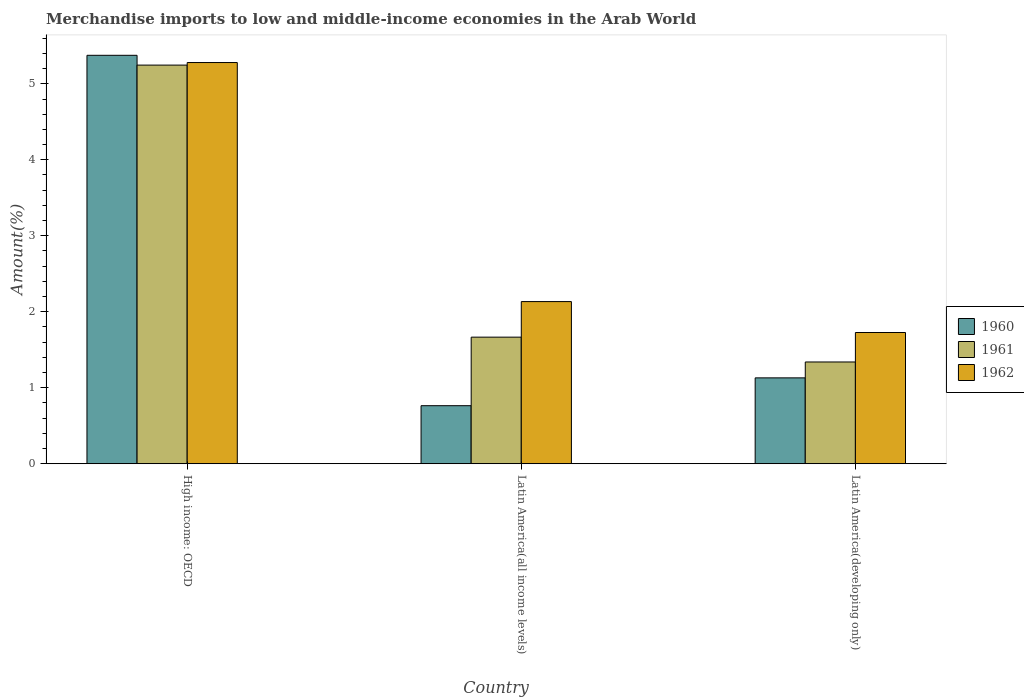Are the number of bars per tick equal to the number of legend labels?
Ensure brevity in your answer.  Yes. Are the number of bars on each tick of the X-axis equal?
Give a very brief answer. Yes. How many bars are there on the 1st tick from the left?
Make the answer very short. 3. How many bars are there on the 3rd tick from the right?
Ensure brevity in your answer.  3. What is the label of the 1st group of bars from the left?
Your answer should be very brief. High income: OECD. In how many cases, is the number of bars for a given country not equal to the number of legend labels?
Your response must be concise. 0. What is the percentage of amount earned from merchandise imports in 1960 in High income: OECD?
Your answer should be very brief. 5.38. Across all countries, what is the maximum percentage of amount earned from merchandise imports in 1962?
Give a very brief answer. 5.28. Across all countries, what is the minimum percentage of amount earned from merchandise imports in 1962?
Make the answer very short. 1.73. In which country was the percentage of amount earned from merchandise imports in 1960 maximum?
Provide a short and direct response. High income: OECD. In which country was the percentage of amount earned from merchandise imports in 1961 minimum?
Provide a short and direct response. Latin America(developing only). What is the total percentage of amount earned from merchandise imports in 1960 in the graph?
Offer a terse response. 7.27. What is the difference between the percentage of amount earned from merchandise imports in 1960 in Latin America(all income levels) and that in Latin America(developing only)?
Give a very brief answer. -0.37. What is the difference between the percentage of amount earned from merchandise imports in 1960 in Latin America(developing only) and the percentage of amount earned from merchandise imports in 1961 in Latin America(all income levels)?
Keep it short and to the point. -0.54. What is the average percentage of amount earned from merchandise imports in 1962 per country?
Offer a very short reply. 3.05. What is the difference between the percentage of amount earned from merchandise imports of/in 1960 and percentage of amount earned from merchandise imports of/in 1961 in High income: OECD?
Offer a very short reply. 0.13. In how many countries, is the percentage of amount earned from merchandise imports in 1962 greater than 3.6 %?
Give a very brief answer. 1. What is the ratio of the percentage of amount earned from merchandise imports in 1961 in High income: OECD to that in Latin America(all income levels)?
Offer a terse response. 3.15. Is the difference between the percentage of amount earned from merchandise imports in 1960 in Latin America(all income levels) and Latin America(developing only) greater than the difference between the percentage of amount earned from merchandise imports in 1961 in Latin America(all income levels) and Latin America(developing only)?
Offer a terse response. No. What is the difference between the highest and the second highest percentage of amount earned from merchandise imports in 1962?
Ensure brevity in your answer.  -0.41. What is the difference between the highest and the lowest percentage of amount earned from merchandise imports in 1960?
Your answer should be compact. 4.61. In how many countries, is the percentage of amount earned from merchandise imports in 1962 greater than the average percentage of amount earned from merchandise imports in 1962 taken over all countries?
Your answer should be compact. 1. Is the sum of the percentage of amount earned from merchandise imports in 1962 in High income: OECD and Latin America(all income levels) greater than the maximum percentage of amount earned from merchandise imports in 1960 across all countries?
Provide a short and direct response. Yes. What does the 2nd bar from the left in Latin America(all income levels) represents?
Provide a succinct answer. 1961. What does the 2nd bar from the right in Latin America(developing only) represents?
Offer a very short reply. 1961. Is it the case that in every country, the sum of the percentage of amount earned from merchandise imports in 1961 and percentage of amount earned from merchandise imports in 1960 is greater than the percentage of amount earned from merchandise imports in 1962?
Make the answer very short. Yes. How many bars are there?
Give a very brief answer. 9. How many countries are there in the graph?
Make the answer very short. 3. What is the difference between two consecutive major ticks on the Y-axis?
Make the answer very short. 1. Are the values on the major ticks of Y-axis written in scientific E-notation?
Your answer should be compact. No. Does the graph contain grids?
Your answer should be very brief. No. Where does the legend appear in the graph?
Offer a terse response. Center right. How many legend labels are there?
Ensure brevity in your answer.  3. How are the legend labels stacked?
Your response must be concise. Vertical. What is the title of the graph?
Keep it short and to the point. Merchandise imports to low and middle-income economies in the Arab World. Does "1970" appear as one of the legend labels in the graph?
Your answer should be compact. No. What is the label or title of the Y-axis?
Provide a succinct answer. Amount(%). What is the Amount(%) of 1960 in High income: OECD?
Provide a short and direct response. 5.38. What is the Amount(%) of 1961 in High income: OECD?
Your response must be concise. 5.25. What is the Amount(%) in 1962 in High income: OECD?
Your answer should be very brief. 5.28. What is the Amount(%) in 1960 in Latin America(all income levels)?
Your answer should be compact. 0.76. What is the Amount(%) in 1961 in Latin America(all income levels)?
Ensure brevity in your answer.  1.67. What is the Amount(%) in 1962 in Latin America(all income levels)?
Provide a succinct answer. 2.13. What is the Amount(%) of 1960 in Latin America(developing only)?
Make the answer very short. 1.13. What is the Amount(%) in 1961 in Latin America(developing only)?
Your response must be concise. 1.34. What is the Amount(%) of 1962 in Latin America(developing only)?
Provide a succinct answer. 1.73. Across all countries, what is the maximum Amount(%) in 1960?
Provide a short and direct response. 5.38. Across all countries, what is the maximum Amount(%) of 1961?
Offer a terse response. 5.25. Across all countries, what is the maximum Amount(%) in 1962?
Provide a short and direct response. 5.28. Across all countries, what is the minimum Amount(%) of 1960?
Make the answer very short. 0.76. Across all countries, what is the minimum Amount(%) of 1961?
Your response must be concise. 1.34. Across all countries, what is the minimum Amount(%) of 1962?
Your answer should be very brief. 1.73. What is the total Amount(%) in 1960 in the graph?
Your response must be concise. 7.27. What is the total Amount(%) in 1961 in the graph?
Offer a terse response. 8.25. What is the total Amount(%) in 1962 in the graph?
Your answer should be very brief. 9.14. What is the difference between the Amount(%) in 1960 in High income: OECD and that in Latin America(all income levels)?
Your answer should be compact. 4.61. What is the difference between the Amount(%) in 1961 in High income: OECD and that in Latin America(all income levels)?
Offer a very short reply. 3.58. What is the difference between the Amount(%) in 1962 in High income: OECD and that in Latin America(all income levels)?
Your answer should be compact. 3.15. What is the difference between the Amount(%) of 1960 in High income: OECD and that in Latin America(developing only)?
Your answer should be very brief. 4.25. What is the difference between the Amount(%) in 1961 in High income: OECD and that in Latin America(developing only)?
Keep it short and to the point. 3.91. What is the difference between the Amount(%) of 1962 in High income: OECD and that in Latin America(developing only)?
Your answer should be compact. 3.55. What is the difference between the Amount(%) of 1960 in Latin America(all income levels) and that in Latin America(developing only)?
Give a very brief answer. -0.37. What is the difference between the Amount(%) of 1961 in Latin America(all income levels) and that in Latin America(developing only)?
Offer a terse response. 0.33. What is the difference between the Amount(%) in 1962 in Latin America(all income levels) and that in Latin America(developing only)?
Give a very brief answer. 0.41. What is the difference between the Amount(%) of 1960 in High income: OECD and the Amount(%) of 1961 in Latin America(all income levels)?
Your response must be concise. 3.71. What is the difference between the Amount(%) in 1960 in High income: OECD and the Amount(%) in 1962 in Latin America(all income levels)?
Keep it short and to the point. 3.24. What is the difference between the Amount(%) in 1961 in High income: OECD and the Amount(%) in 1962 in Latin America(all income levels)?
Provide a short and direct response. 3.11. What is the difference between the Amount(%) of 1960 in High income: OECD and the Amount(%) of 1961 in Latin America(developing only)?
Make the answer very short. 4.04. What is the difference between the Amount(%) in 1960 in High income: OECD and the Amount(%) in 1962 in Latin America(developing only)?
Ensure brevity in your answer.  3.65. What is the difference between the Amount(%) of 1961 in High income: OECD and the Amount(%) of 1962 in Latin America(developing only)?
Your answer should be very brief. 3.52. What is the difference between the Amount(%) in 1960 in Latin America(all income levels) and the Amount(%) in 1961 in Latin America(developing only)?
Your answer should be very brief. -0.58. What is the difference between the Amount(%) of 1960 in Latin America(all income levels) and the Amount(%) of 1962 in Latin America(developing only)?
Your response must be concise. -0.96. What is the difference between the Amount(%) of 1961 in Latin America(all income levels) and the Amount(%) of 1962 in Latin America(developing only)?
Offer a terse response. -0.06. What is the average Amount(%) in 1960 per country?
Your response must be concise. 2.42. What is the average Amount(%) in 1961 per country?
Give a very brief answer. 2.75. What is the average Amount(%) of 1962 per country?
Your response must be concise. 3.05. What is the difference between the Amount(%) of 1960 and Amount(%) of 1961 in High income: OECD?
Provide a succinct answer. 0.13. What is the difference between the Amount(%) of 1960 and Amount(%) of 1962 in High income: OECD?
Provide a short and direct response. 0.1. What is the difference between the Amount(%) of 1961 and Amount(%) of 1962 in High income: OECD?
Offer a terse response. -0.03. What is the difference between the Amount(%) of 1960 and Amount(%) of 1961 in Latin America(all income levels)?
Provide a succinct answer. -0.9. What is the difference between the Amount(%) of 1960 and Amount(%) of 1962 in Latin America(all income levels)?
Provide a short and direct response. -1.37. What is the difference between the Amount(%) of 1961 and Amount(%) of 1962 in Latin America(all income levels)?
Keep it short and to the point. -0.47. What is the difference between the Amount(%) in 1960 and Amount(%) in 1961 in Latin America(developing only)?
Give a very brief answer. -0.21. What is the difference between the Amount(%) of 1960 and Amount(%) of 1962 in Latin America(developing only)?
Your answer should be compact. -0.6. What is the difference between the Amount(%) of 1961 and Amount(%) of 1962 in Latin America(developing only)?
Provide a succinct answer. -0.39. What is the ratio of the Amount(%) in 1960 in High income: OECD to that in Latin America(all income levels)?
Provide a succinct answer. 7.04. What is the ratio of the Amount(%) in 1961 in High income: OECD to that in Latin America(all income levels)?
Give a very brief answer. 3.15. What is the ratio of the Amount(%) of 1962 in High income: OECD to that in Latin America(all income levels)?
Keep it short and to the point. 2.47. What is the ratio of the Amount(%) in 1960 in High income: OECD to that in Latin America(developing only)?
Offer a very short reply. 4.76. What is the ratio of the Amount(%) in 1961 in High income: OECD to that in Latin America(developing only)?
Provide a short and direct response. 3.92. What is the ratio of the Amount(%) in 1962 in High income: OECD to that in Latin America(developing only)?
Offer a very short reply. 3.06. What is the ratio of the Amount(%) of 1960 in Latin America(all income levels) to that in Latin America(developing only)?
Provide a short and direct response. 0.68. What is the ratio of the Amount(%) in 1961 in Latin America(all income levels) to that in Latin America(developing only)?
Your answer should be compact. 1.24. What is the ratio of the Amount(%) of 1962 in Latin America(all income levels) to that in Latin America(developing only)?
Your answer should be very brief. 1.24. What is the difference between the highest and the second highest Amount(%) of 1960?
Your answer should be compact. 4.25. What is the difference between the highest and the second highest Amount(%) in 1961?
Provide a short and direct response. 3.58. What is the difference between the highest and the second highest Amount(%) in 1962?
Your answer should be very brief. 3.15. What is the difference between the highest and the lowest Amount(%) of 1960?
Your answer should be very brief. 4.61. What is the difference between the highest and the lowest Amount(%) in 1961?
Offer a very short reply. 3.91. What is the difference between the highest and the lowest Amount(%) in 1962?
Make the answer very short. 3.55. 